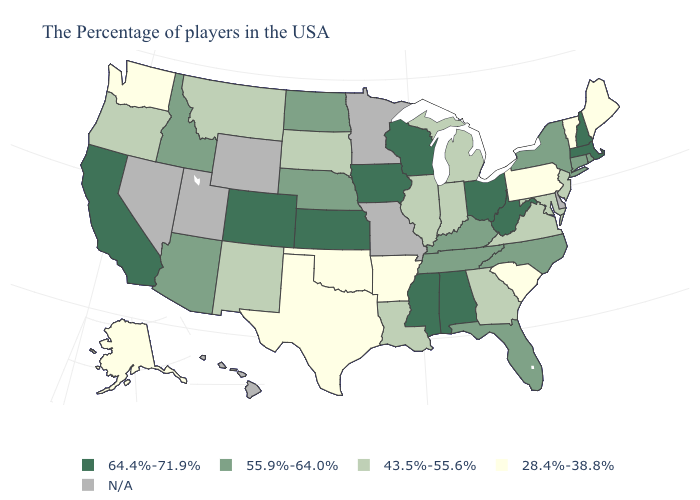What is the value of West Virginia?
Answer briefly. 64.4%-71.9%. Is the legend a continuous bar?
Short answer required. No. Does Vermont have the highest value in the Northeast?
Write a very short answer. No. Name the states that have a value in the range 43.5%-55.6%?
Give a very brief answer. New Jersey, Maryland, Virginia, Georgia, Michigan, Indiana, Illinois, Louisiana, South Dakota, New Mexico, Montana, Oregon. What is the value of Wyoming?
Keep it brief. N/A. Name the states that have a value in the range 28.4%-38.8%?
Be succinct. Maine, Vermont, Pennsylvania, South Carolina, Arkansas, Oklahoma, Texas, Washington, Alaska. Among the states that border Nebraska , does Kansas have the highest value?
Concise answer only. Yes. What is the lowest value in the USA?
Write a very short answer. 28.4%-38.8%. What is the value of New York?
Quick response, please. 55.9%-64.0%. Does New Hampshire have the highest value in the USA?
Short answer required. Yes. Among the states that border Vermont , does New York have the highest value?
Answer briefly. No. Which states have the highest value in the USA?
Answer briefly. Massachusetts, New Hampshire, West Virginia, Ohio, Alabama, Wisconsin, Mississippi, Iowa, Kansas, Colorado, California. Does the first symbol in the legend represent the smallest category?
Be succinct. No. What is the value of Maryland?
Quick response, please. 43.5%-55.6%. What is the value of Rhode Island?
Concise answer only. 55.9%-64.0%. 